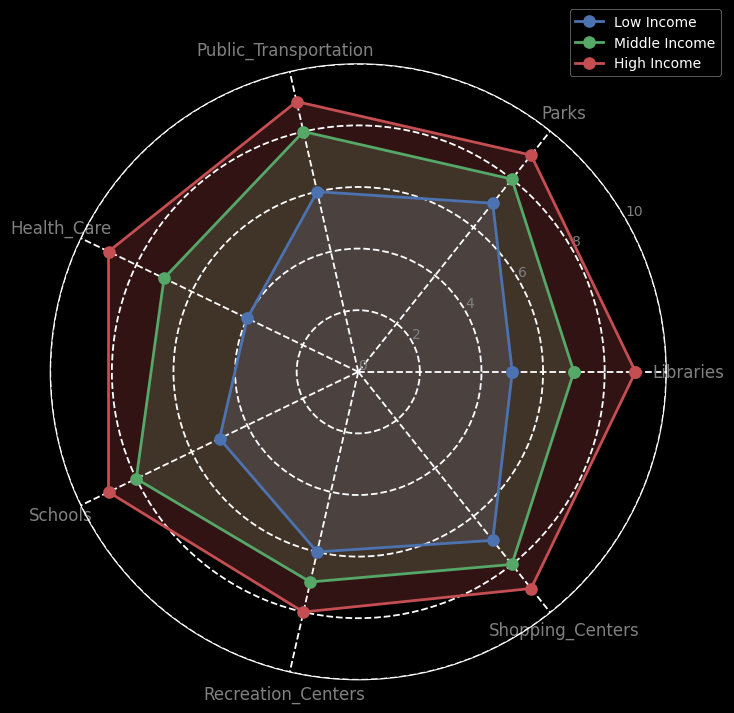What's the average access score for libraries among all socioeconomic groups? Calculate the sum of the library scores for all groups: 5 (Low Income) + 7 (Middle Income) + 9 (High Income) = 21. Divide the sum by the number of groups (3): 21 / 3 = 7.
Answer: 7 Which socioeconomic group has the lowest access to health care? Compare the health care access scores: 4 (Low Income), 7 (Middle Income), 9 (High Income). The lowest score is for the Low Income group.
Answer: Low Income How does the middle-income group's access to shopping centers compare to the low-income group's access to public transportation? The middle-income group's score for shopping centers is 8. The low-income group's score for public transportation is 6. Therefore, the middle-income group has a higher score for shopping centers compared to the low-income group's score for public transportation.
Answer: Middle Income has higher Which socioeconomic group has the most balanced (least variance) access across all public amenities? Calculate the variance of access scores for each group:
- Low Income: Scores are [5, 7, 6, 4, 5, 6, 7]. Variance is approximately 1.14.
- Middle Income: Scores are [7, 8, 8, 7, 8, 7, 8]. Variance is approximately 0.14.
- High Income: Scores are [9, 9, 9, 9, 9, 8, 9]. Variance is approximately 0.14.
The Middle Income and High Income groups both have the lowest variance.
Answer: Middle Income & High Income What is the sum of the access scores for parks and recreation centers for the high-income group? Add the scores for parks and recreation centers for the High Income group: 9 (Parks) + 8 (Recreation Centers) = 17.
Answer: 17 For which public amenity do all groups have the same score of 7? Look at the scores for each public amenity across all groups: only Shopping Centers have scores of 7 for Low, Middle, and High-income groups respectively.
Answer: Shopping Centers Between low-income and high-income groups, which has significantly better access to schools? Compare the access scores to schools: Low Income has a score of 5, while High Income has a score of 9. High Income has better access by 4 points.
Answer: High Income has better access What are the categories where the middle-income group scores exactly in the middle of the other two groups? Compare the scores for each category to see where the middle-income group's scores are in between the scores of low and high-income groups:
- Libraries: 5 (Low), 7 (Middle), 9 (High)
- Public Transportation: 6 (Low), 8 (Middle), 9 (High)
- Health Care: 4 (Low), 7 (Middle), 9 (High)
- Schools: 5 (Low), 8 (Middle), 9 (High)
- Recreation Centers: 6 (Low), 7 (Middle), 8 (High)
The middle-income scores fall between the other two groups for Libraries, Public Transportation, Health Care, Schools, and Recreation Centers.
Answer: Libraries, Public Transportation, Health Care, Schools, Recreation Centers 